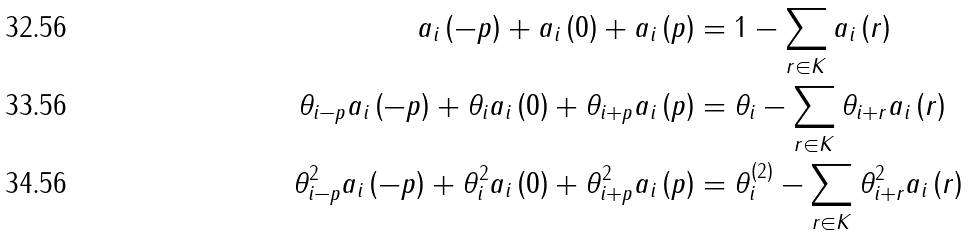<formula> <loc_0><loc_0><loc_500><loc_500>a _ { i } \left ( - p \right ) + a _ { i } \left ( 0 \right ) + a _ { i } \left ( p \right ) & = 1 - \sum _ { r \in K } a _ { i } \left ( r \right ) \\ \theta _ { i - p } a _ { i } \left ( - p \right ) + \theta _ { i } a _ { i } \left ( 0 \right ) + \theta _ { i + p } a _ { i } \left ( p \right ) & = \theta _ { i } - \sum _ { r \in K } \theta _ { i + r } a _ { i } \left ( r \right ) \\ \theta _ { i - p } ^ { 2 } a _ { i } \left ( - p \right ) + \theta _ { i } ^ { 2 } a _ { i } \left ( 0 \right ) + \theta _ { i + p } ^ { 2 } a _ { i } \left ( p \right ) & = \theta _ { i } ^ { \left ( 2 \right ) } - \sum _ { r \in K } \theta _ { i + r } ^ { 2 } a _ { i } \left ( r \right )</formula> 